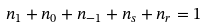<formula> <loc_0><loc_0><loc_500><loc_500>n _ { 1 } + n _ { 0 } + n _ { - 1 } + n _ { s } + n _ { r } = 1</formula> 